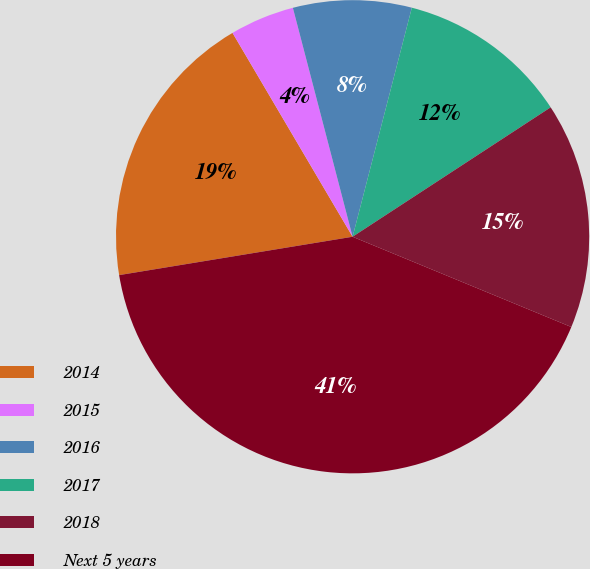<chart> <loc_0><loc_0><loc_500><loc_500><pie_chart><fcel>2014<fcel>2015<fcel>2016<fcel>2017<fcel>2018<fcel>Next 5 years<nl><fcel>19.12%<fcel>4.41%<fcel>8.09%<fcel>11.76%<fcel>15.44%<fcel>41.18%<nl></chart> 